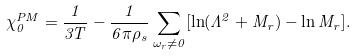<formula> <loc_0><loc_0><loc_500><loc_500>\chi _ { 0 } ^ { P M } = \frac { 1 } { 3 T } - \frac { 1 } { 6 \pi \rho _ { s } } \sum _ { \omega _ { r } \neq 0 } [ \ln ( \Lambda ^ { 2 } + M _ { r } ) - \ln M _ { r } ] .</formula> 